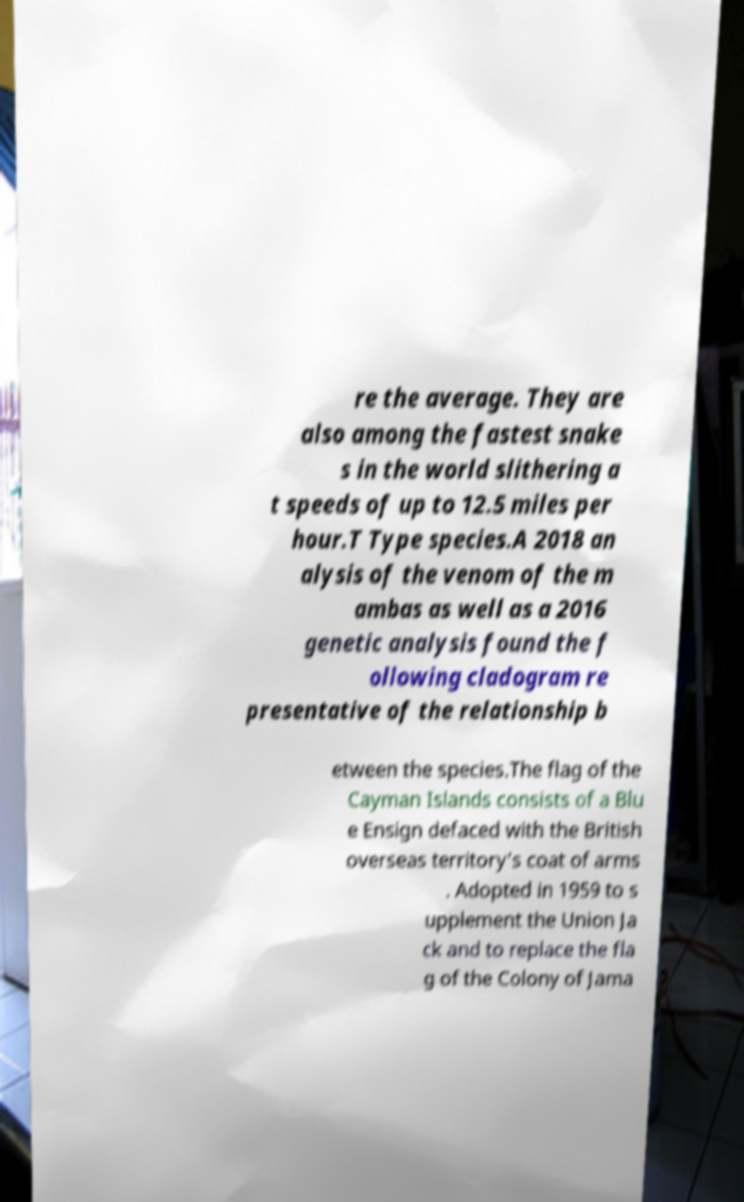Can you read and provide the text displayed in the image?This photo seems to have some interesting text. Can you extract and type it out for me? re the average. They are also among the fastest snake s in the world slithering a t speeds of up to 12.5 miles per hour.T Type species.A 2018 an alysis of the venom of the m ambas as well as a 2016 genetic analysis found the f ollowing cladogram re presentative of the relationship b etween the species.The flag of the Cayman Islands consists of a Blu e Ensign defaced with the British overseas territory's coat of arms . Adopted in 1959 to s upplement the Union Ja ck and to replace the fla g of the Colony of Jama 